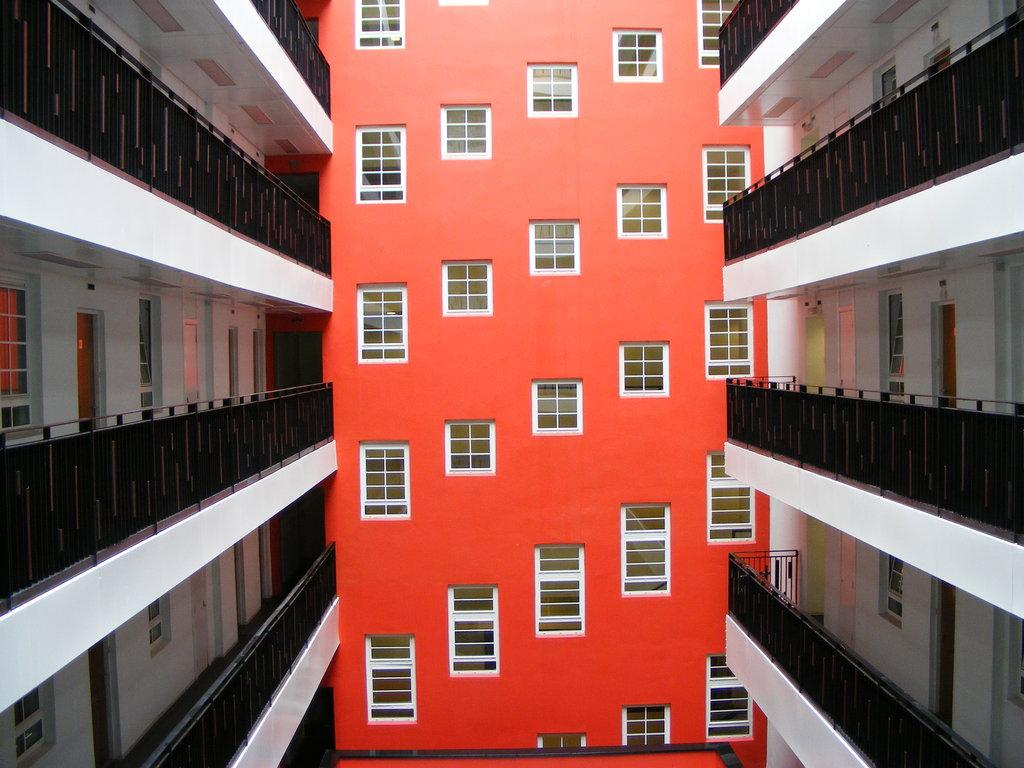What can be seen on the right side of the image? There are buildings on the right side of the image. What can be seen on the left side of the image? There are buildings on the left side of the image. What is the most prominent building in the image? There is a red color building in the center of the image. How many windows does the red color building have? The red color building has many windows. Can you see a robin perched on the red color building in the image? There is no robin present in the image. How many fingers are visible on the buildings in the image? Buildings do not have fingers, so this question cannot be answered based on the image. 